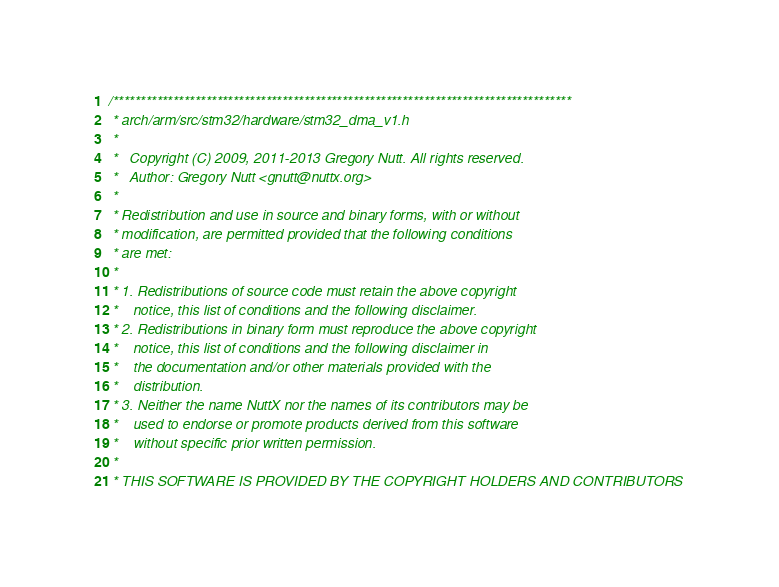Convert code to text. <code><loc_0><loc_0><loc_500><loc_500><_C_>/************************************************************************************
 * arch/arm/src/stm32/hardware/stm32_dma_v1.h
 *
 *   Copyright (C) 2009, 2011-2013 Gregory Nutt. All rights reserved.
 *   Author: Gregory Nutt <gnutt@nuttx.org>
 *
 * Redistribution and use in source and binary forms, with or without
 * modification, are permitted provided that the following conditions
 * are met:
 *
 * 1. Redistributions of source code must retain the above copyright
 *    notice, this list of conditions and the following disclaimer.
 * 2. Redistributions in binary form must reproduce the above copyright
 *    notice, this list of conditions and the following disclaimer in
 *    the documentation and/or other materials provided with the
 *    distribution.
 * 3. Neither the name NuttX nor the names of its contributors may be
 *    used to endorse or promote products derived from this software
 *    without specific prior written permission.
 *
 * THIS SOFTWARE IS PROVIDED BY THE COPYRIGHT HOLDERS AND CONTRIBUTORS</code> 